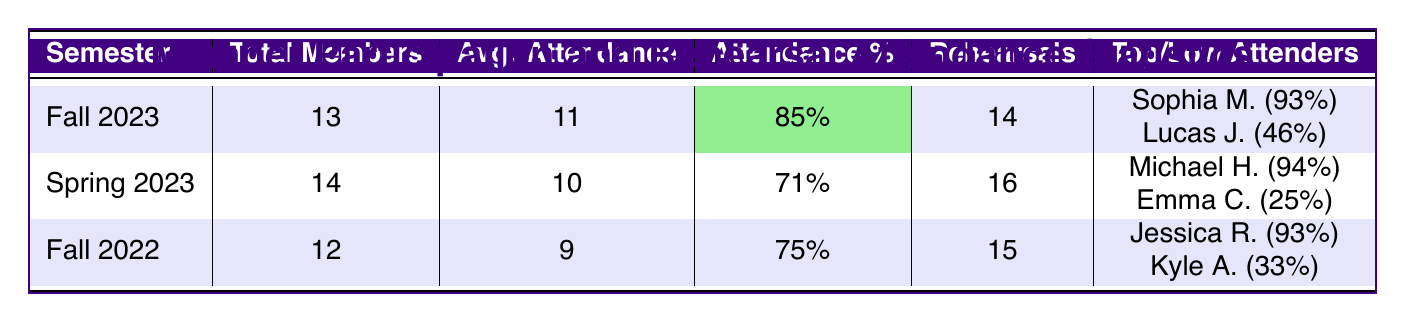What is the total number of members in Spring 2023? In the table, under the Spring 2023 row, the value in the "Total Members" column is listed as 14.
Answer: 14 Who had the highest attendance in Fall 2022? The top attender for Fall 2022 is listed in the highlights section as Jessica Reynolds, with an attendance of 14.
Answer: Jessica Reynolds What was the average attendance for Fall 2023? In the Fall 2023 row, the "Avg. Attendance" is recorded as 11.
Answer: 11 How many rehearsals were conducted in Spring 2023? Looking at the Spring 2023 row, the value under "Rehearsals" is recorded as 16.
Answer: 16 What is the percentage attendance for Fall 2023? The table shows that the "Attendance %" for Fall 2023 is highlighted and recorded as 85%.
Answer: 85% Which semester had the lowest average attendance? Comparing the averages in the table, Fall 2022 has the lowest average attendance at 9.
Answer: Fall 2022 How many more rehearsals were conducted in Spring 2023 compared to Fall 2023? Spring 2023 had 16 rehearsals, while Fall 2023 had 14. Subtracting gives 16 - 14 = 2.
Answer: 2 What is the participation rate of the low attender in Fall 2023? The low attender for Fall 2023 was Lucas Johnson, and his participation rate is recorded as 46%.
Answer: 46% Is the average attendance in Spring 2023 higher than Fall 2022? The average attendance for Spring 2023 is 10, while for Fall 2022 it is 9. Since 10 > 9, the answer is yes.
Answer: Yes What is the difference in average attendance between Fall 2023 and Spring 2023? The average attendance for Fall 2023 is 11, and for Spring 2023, it is 10. The difference is 11 - 10 = 1.
Answer: 1 Which semester had a top attender with a participation rate above 90%? Fall 2022 and Spring 2023 both had top attenders, Jessica Reynolds and Michael Hughes, respectively, with participation rates of 93% and 94%.
Answer: Fall 2022 and Spring 2023 What percentage of members attended at least one rehearsal in Fall 2022? In Fall 2022, 9 out of 12 members attended rehearsals, which gives (9/12)*100 = 75%. The attendance is confirmed to be 75%.
Answer: 75% 